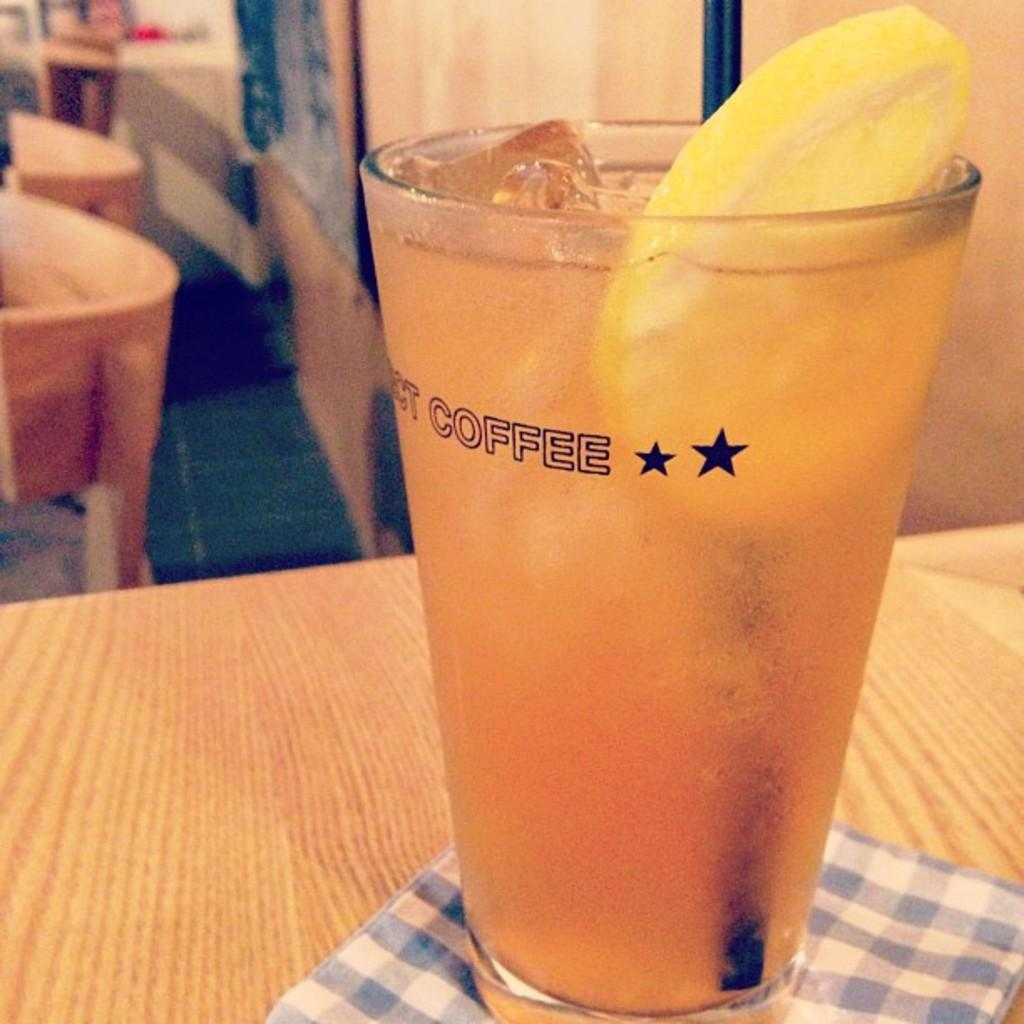What piece of furniture is present in the image? There is a table in the image. What is placed on the table? There is a glass of shake on the table. What type of kite is flying above the table in the image? There is no kite present in the image; it only features a table and a glass of shake. How many hens are sitting on the table in the image? There are no hens present in the image; it only features a table and a glass of shake. 